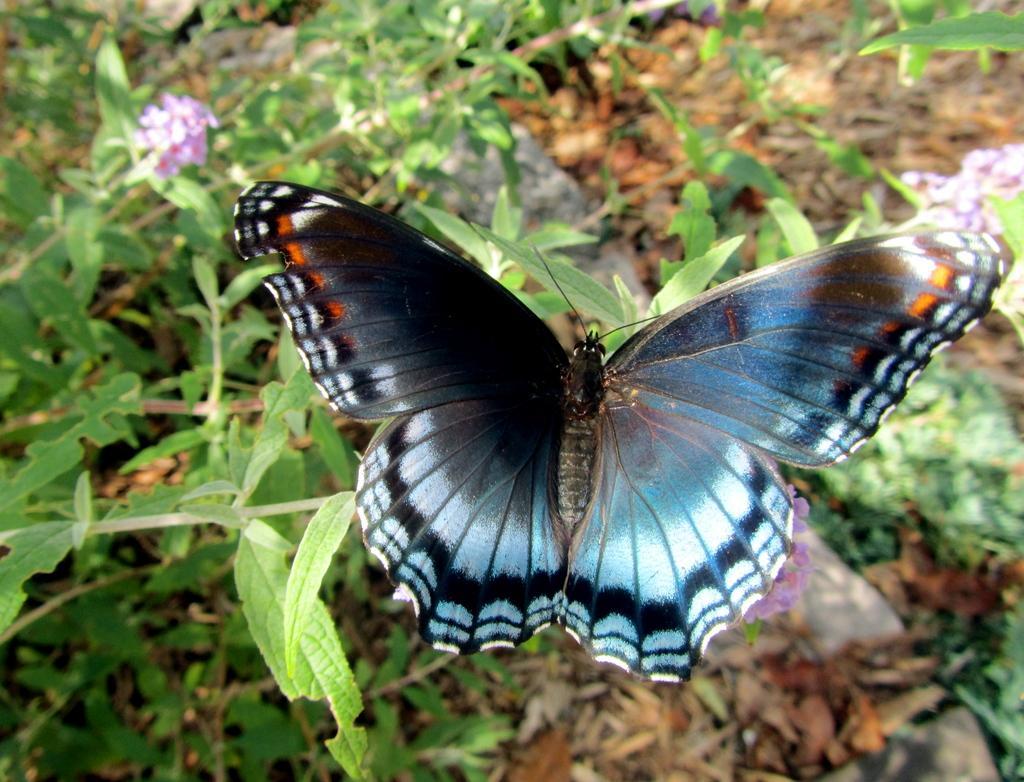How would you summarize this image in a sentence or two? In this image, we can see a butterfly on the plant. 